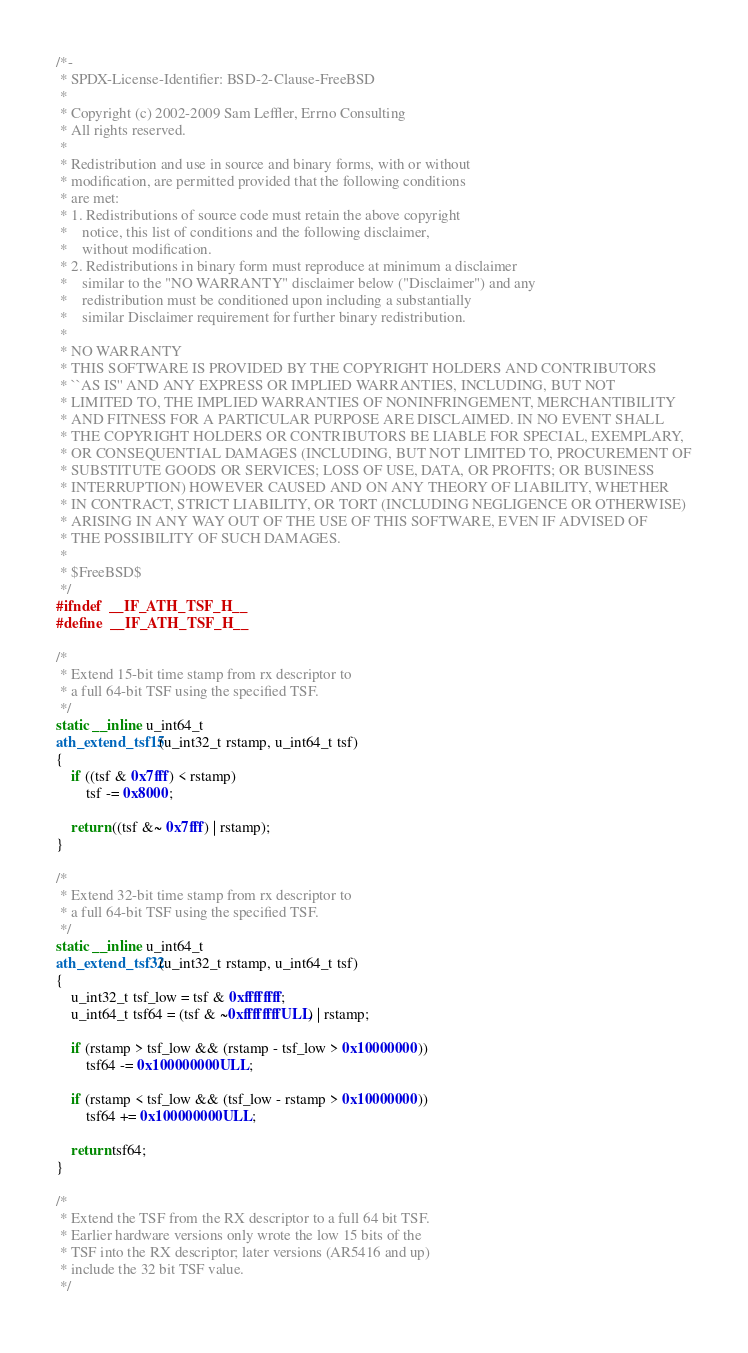Convert code to text. <code><loc_0><loc_0><loc_500><loc_500><_C_>/*-
 * SPDX-License-Identifier: BSD-2-Clause-FreeBSD
 *
 * Copyright (c) 2002-2009 Sam Leffler, Errno Consulting
 * All rights reserved.
 *
 * Redistribution and use in source and binary forms, with or without
 * modification, are permitted provided that the following conditions
 * are met:
 * 1. Redistributions of source code must retain the above copyright
 *    notice, this list of conditions and the following disclaimer,
 *    without modification.
 * 2. Redistributions in binary form must reproduce at minimum a disclaimer
 *    similar to the "NO WARRANTY" disclaimer below ("Disclaimer") and any
 *    redistribution must be conditioned upon including a substantially
 *    similar Disclaimer requirement for further binary redistribution.
 *
 * NO WARRANTY
 * THIS SOFTWARE IS PROVIDED BY THE COPYRIGHT HOLDERS AND CONTRIBUTORS
 * ``AS IS'' AND ANY EXPRESS OR IMPLIED WARRANTIES, INCLUDING, BUT NOT
 * LIMITED TO, THE IMPLIED WARRANTIES OF NONINFRINGEMENT, MERCHANTIBILITY
 * AND FITNESS FOR A PARTICULAR PURPOSE ARE DISCLAIMED. IN NO EVENT SHALL
 * THE COPYRIGHT HOLDERS OR CONTRIBUTORS BE LIABLE FOR SPECIAL, EXEMPLARY,
 * OR CONSEQUENTIAL DAMAGES (INCLUDING, BUT NOT LIMITED TO, PROCUREMENT OF
 * SUBSTITUTE GOODS OR SERVICES; LOSS OF USE, DATA, OR PROFITS; OR BUSINESS
 * INTERRUPTION) HOWEVER CAUSED AND ON ANY THEORY OF LIABILITY, WHETHER
 * IN CONTRACT, STRICT LIABILITY, OR TORT (INCLUDING NEGLIGENCE OR OTHERWISE)
 * ARISING IN ANY WAY OUT OF THE USE OF THIS SOFTWARE, EVEN IF ADVISED OF
 * THE POSSIBILITY OF SUCH DAMAGES.
 *
 * $FreeBSD$
 */
#ifndef	__IF_ATH_TSF_H__
#define	__IF_ATH_TSF_H__

/*
 * Extend 15-bit time stamp from rx descriptor to
 * a full 64-bit TSF using the specified TSF.
 */
static __inline u_int64_t
ath_extend_tsf15(u_int32_t rstamp, u_int64_t tsf)
{
	if ((tsf & 0x7fff) < rstamp)
		tsf -= 0x8000;

	return ((tsf &~ 0x7fff) | rstamp);
}

/*
 * Extend 32-bit time stamp from rx descriptor to
 * a full 64-bit TSF using the specified TSF.
 */
static __inline u_int64_t
ath_extend_tsf32(u_int32_t rstamp, u_int64_t tsf)
{
	u_int32_t tsf_low = tsf & 0xffffffff;
	u_int64_t tsf64 = (tsf & ~0xffffffffULL) | rstamp;

	if (rstamp > tsf_low && (rstamp - tsf_low > 0x10000000))
		tsf64 -= 0x100000000ULL;

	if (rstamp < tsf_low && (tsf_low - rstamp > 0x10000000))
		tsf64 += 0x100000000ULL;

	return tsf64;
}

/*
 * Extend the TSF from the RX descriptor to a full 64 bit TSF.
 * Earlier hardware versions only wrote the low 15 bits of the
 * TSF into the RX descriptor; later versions (AR5416 and up)
 * include the 32 bit TSF value.
 */</code> 